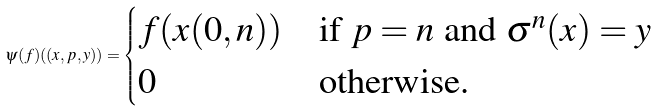<formula> <loc_0><loc_0><loc_500><loc_500>\psi ( f ) ( ( x , p , y ) ) = \begin{cases} f ( x ( 0 , n ) ) & \text {if $p = n$ and $\sigma^{n} (x) = y$} \\ 0 & \text {otherwise.} \end{cases}</formula> 